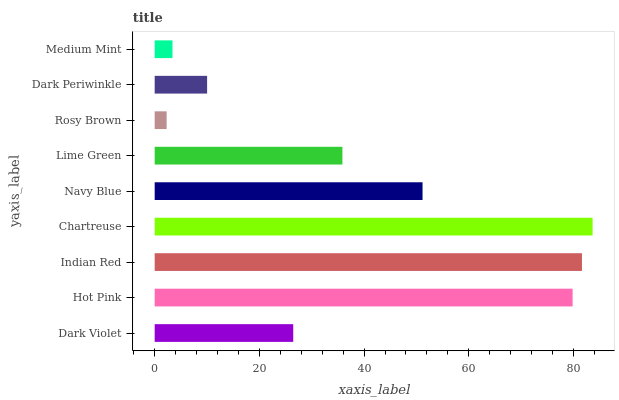Is Rosy Brown the minimum?
Answer yes or no. Yes. Is Chartreuse the maximum?
Answer yes or no. Yes. Is Hot Pink the minimum?
Answer yes or no. No. Is Hot Pink the maximum?
Answer yes or no. No. Is Hot Pink greater than Dark Violet?
Answer yes or no. Yes. Is Dark Violet less than Hot Pink?
Answer yes or no. Yes. Is Dark Violet greater than Hot Pink?
Answer yes or no. No. Is Hot Pink less than Dark Violet?
Answer yes or no. No. Is Lime Green the high median?
Answer yes or no. Yes. Is Lime Green the low median?
Answer yes or no. Yes. Is Dark Periwinkle the high median?
Answer yes or no. No. Is Navy Blue the low median?
Answer yes or no. No. 